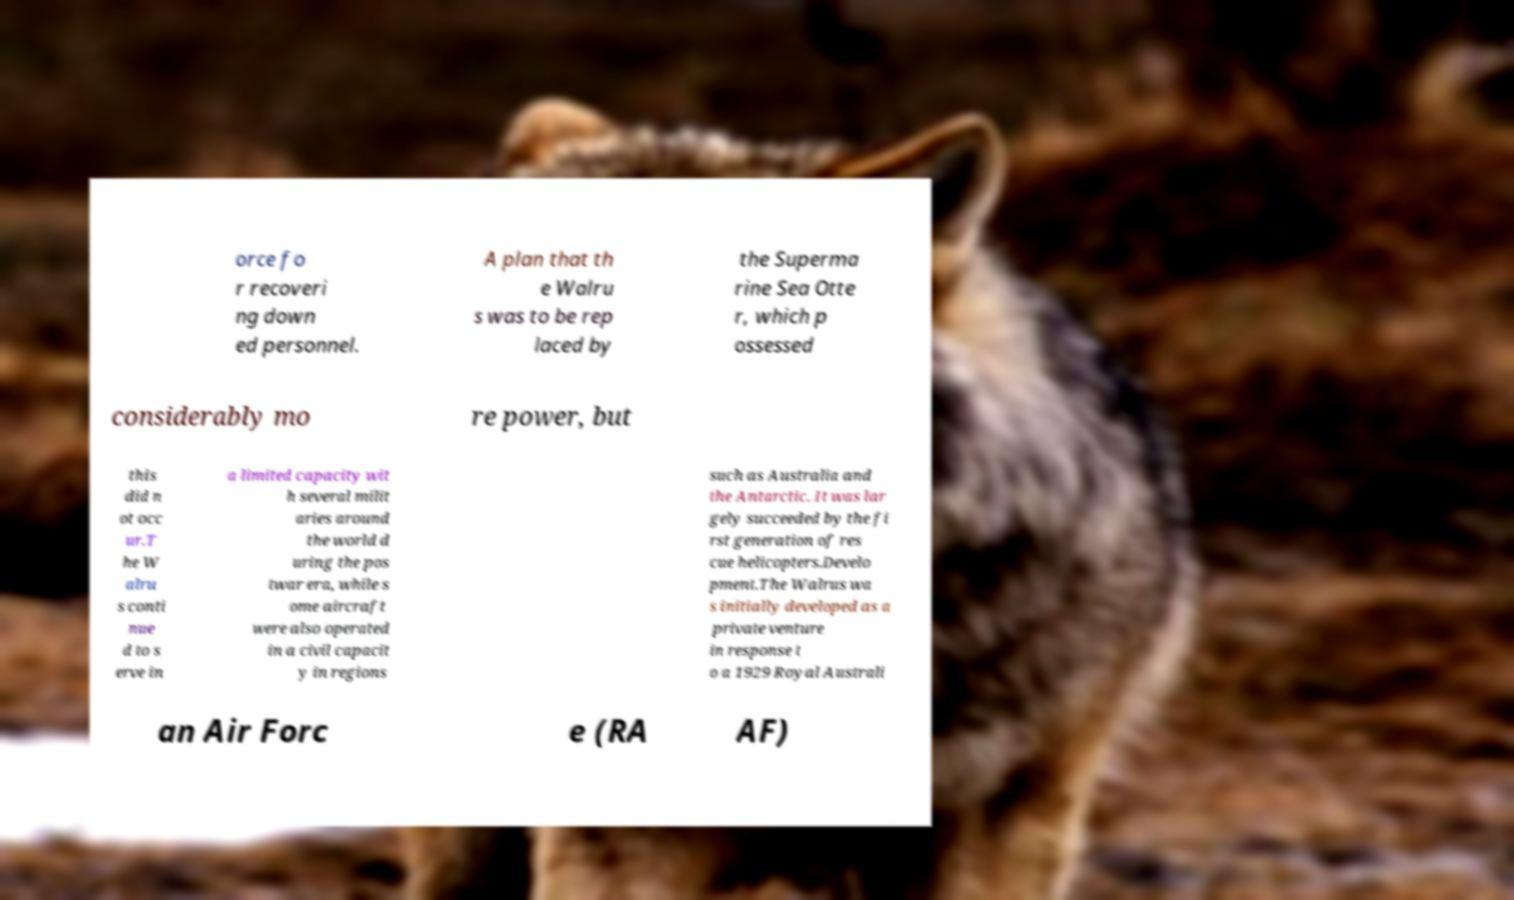Please read and relay the text visible in this image. What does it say? orce fo r recoveri ng down ed personnel. A plan that th e Walru s was to be rep laced by the Superma rine Sea Otte r, which p ossessed considerably mo re power, but this did n ot occ ur.T he W alru s conti nue d to s erve in a limited capacity wit h several milit aries around the world d uring the pos twar era, while s ome aircraft were also operated in a civil capacit y in regions such as Australia and the Antarctic. It was lar gely succeeded by the fi rst generation of res cue helicopters.Develo pment.The Walrus wa s initially developed as a private venture in response t o a 1929 Royal Australi an Air Forc e (RA AF) 